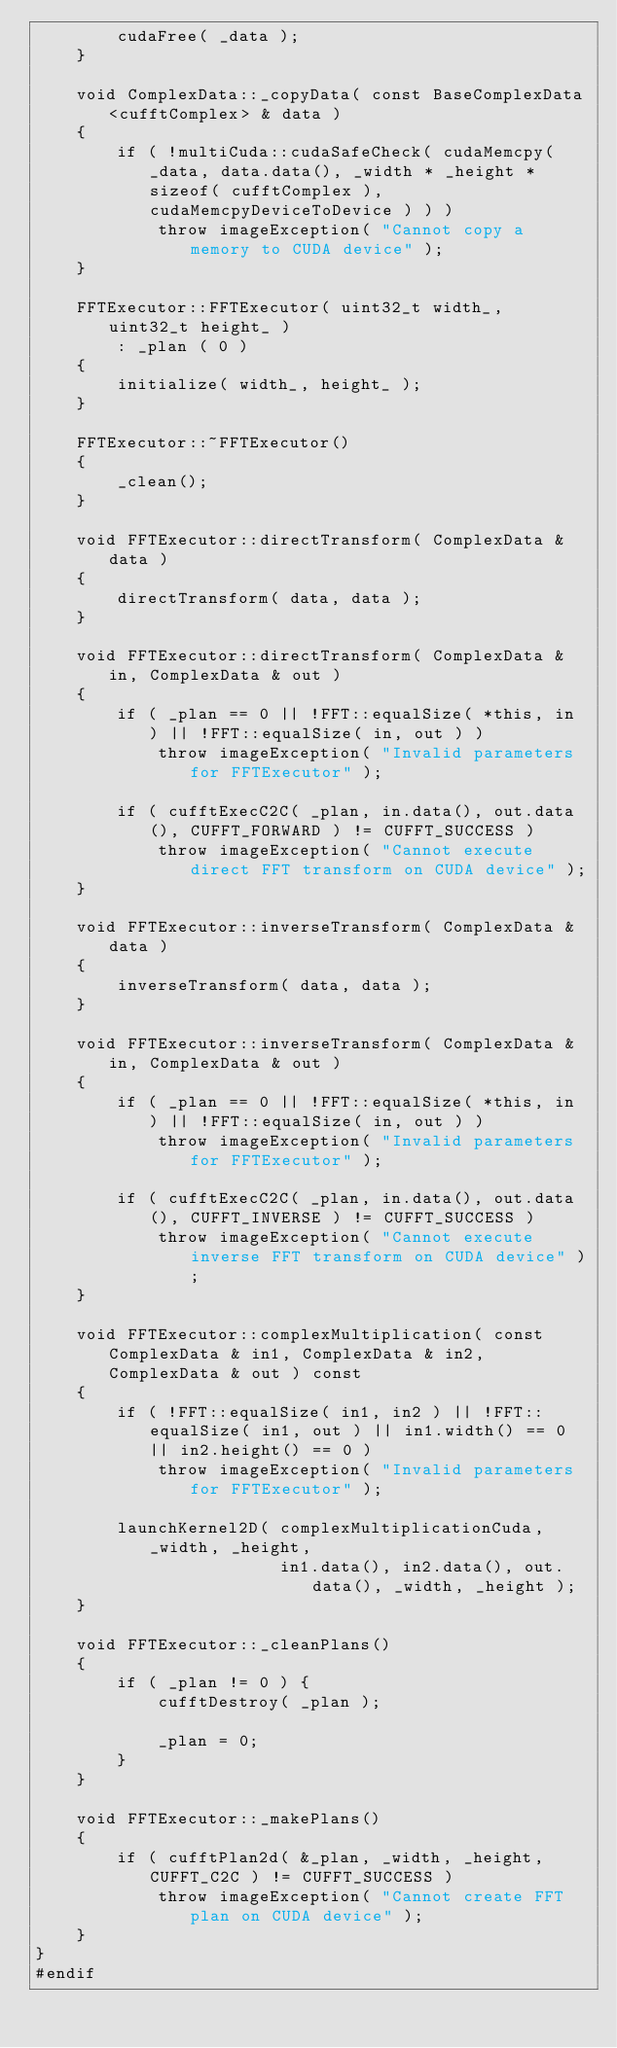<code> <loc_0><loc_0><loc_500><loc_500><_Cuda_>        cudaFree( _data );
    }

    void ComplexData::_copyData( const BaseComplexData<cufftComplex> & data )
    {
        if ( !multiCuda::cudaSafeCheck( cudaMemcpy( _data, data.data(), _width * _height * sizeof( cufftComplex ), cudaMemcpyDeviceToDevice ) ) )
            throw imageException( "Cannot copy a memory to CUDA device" );
    }

    FFTExecutor::FFTExecutor( uint32_t width_, uint32_t height_ )
        : _plan ( 0 )
    {
        initialize( width_, height_ );
    }

    FFTExecutor::~FFTExecutor()
    {
        _clean();
    }

    void FFTExecutor::directTransform( ComplexData & data )
    {
        directTransform( data, data );
    }

    void FFTExecutor::directTransform( ComplexData & in, ComplexData & out )
    {
        if ( _plan == 0 || !FFT::equalSize( *this, in ) || !FFT::equalSize( in, out ) )
            throw imageException( "Invalid parameters for FFTExecutor" );

        if ( cufftExecC2C( _plan, in.data(), out.data(), CUFFT_FORWARD ) != CUFFT_SUCCESS )
            throw imageException( "Cannot execute direct FFT transform on CUDA device" );
    }

    void FFTExecutor::inverseTransform( ComplexData & data )
    {
        inverseTransform( data, data );
    }

    void FFTExecutor::inverseTransform( ComplexData & in, ComplexData & out )
    {
        if ( _plan == 0 || !FFT::equalSize( *this, in ) || !FFT::equalSize( in, out ) )
            throw imageException( "Invalid parameters for FFTExecutor" );

        if ( cufftExecC2C( _plan, in.data(), out.data(), CUFFT_INVERSE ) != CUFFT_SUCCESS )
            throw imageException( "Cannot execute inverse FFT transform on CUDA device" );
    }

    void FFTExecutor::complexMultiplication( const ComplexData & in1, ComplexData & in2, ComplexData & out ) const
    {
        if ( !FFT::equalSize( in1, in2 ) || !FFT::equalSize( in1, out ) || in1.width() == 0 || in2.height() == 0 )
            throw imageException( "Invalid parameters for FFTExecutor" );

        launchKernel2D( complexMultiplicationCuda, _width, _height,
                        in1.data(), in2.data(), out.data(), _width, _height );
    }

    void FFTExecutor::_cleanPlans()
    {
        if ( _plan != 0 ) {
            cufftDestroy( _plan );

            _plan = 0;
        }
    }

    void FFTExecutor::_makePlans()
    {
        if ( cufftPlan2d( &_plan, _width, _height, CUFFT_C2C ) != CUFFT_SUCCESS )
            throw imageException( "Cannot create FFT plan on CUDA device" );
    }
}
#endif
</code> 